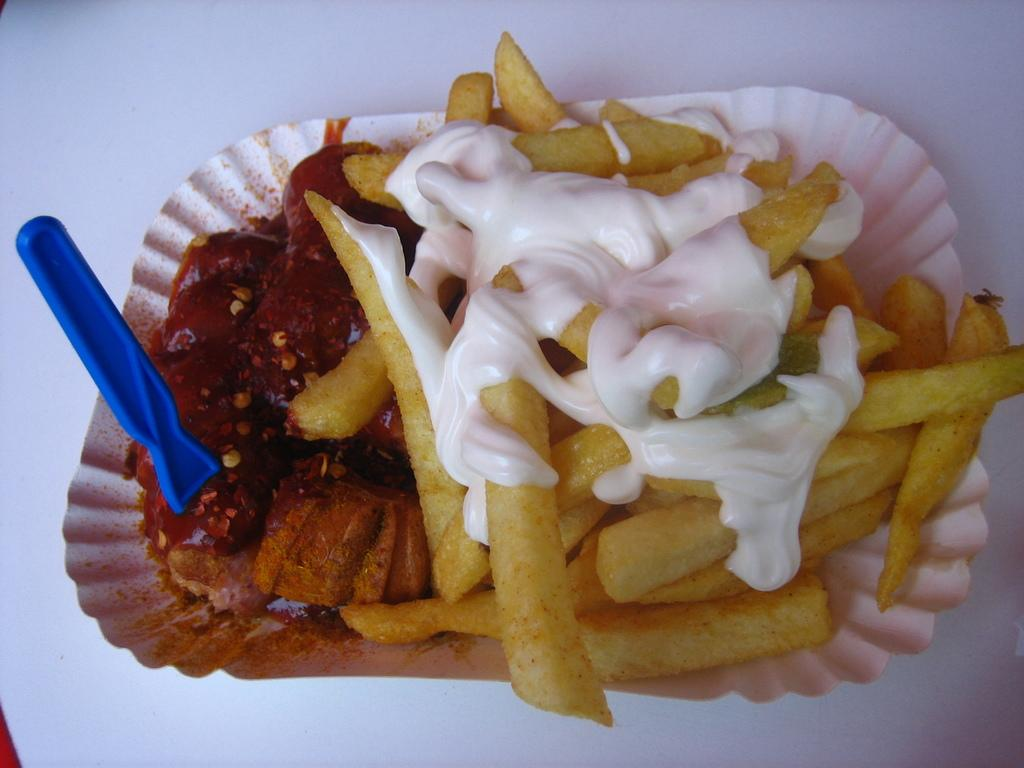What is on the table in the image? There is a paper plate on the table. What is on the paper plate? There is food on the plate, including french fries. What utensil is on the plate? There is a spoon on the plate. What is on the french fries? There is sauce on the french fries. What type of silk is being used to make the team uniforms in the image? There is no reference to silk, team uniforms, or a business in the image; it features a paper plate with food, a spoon, and sauce on the french fries. 